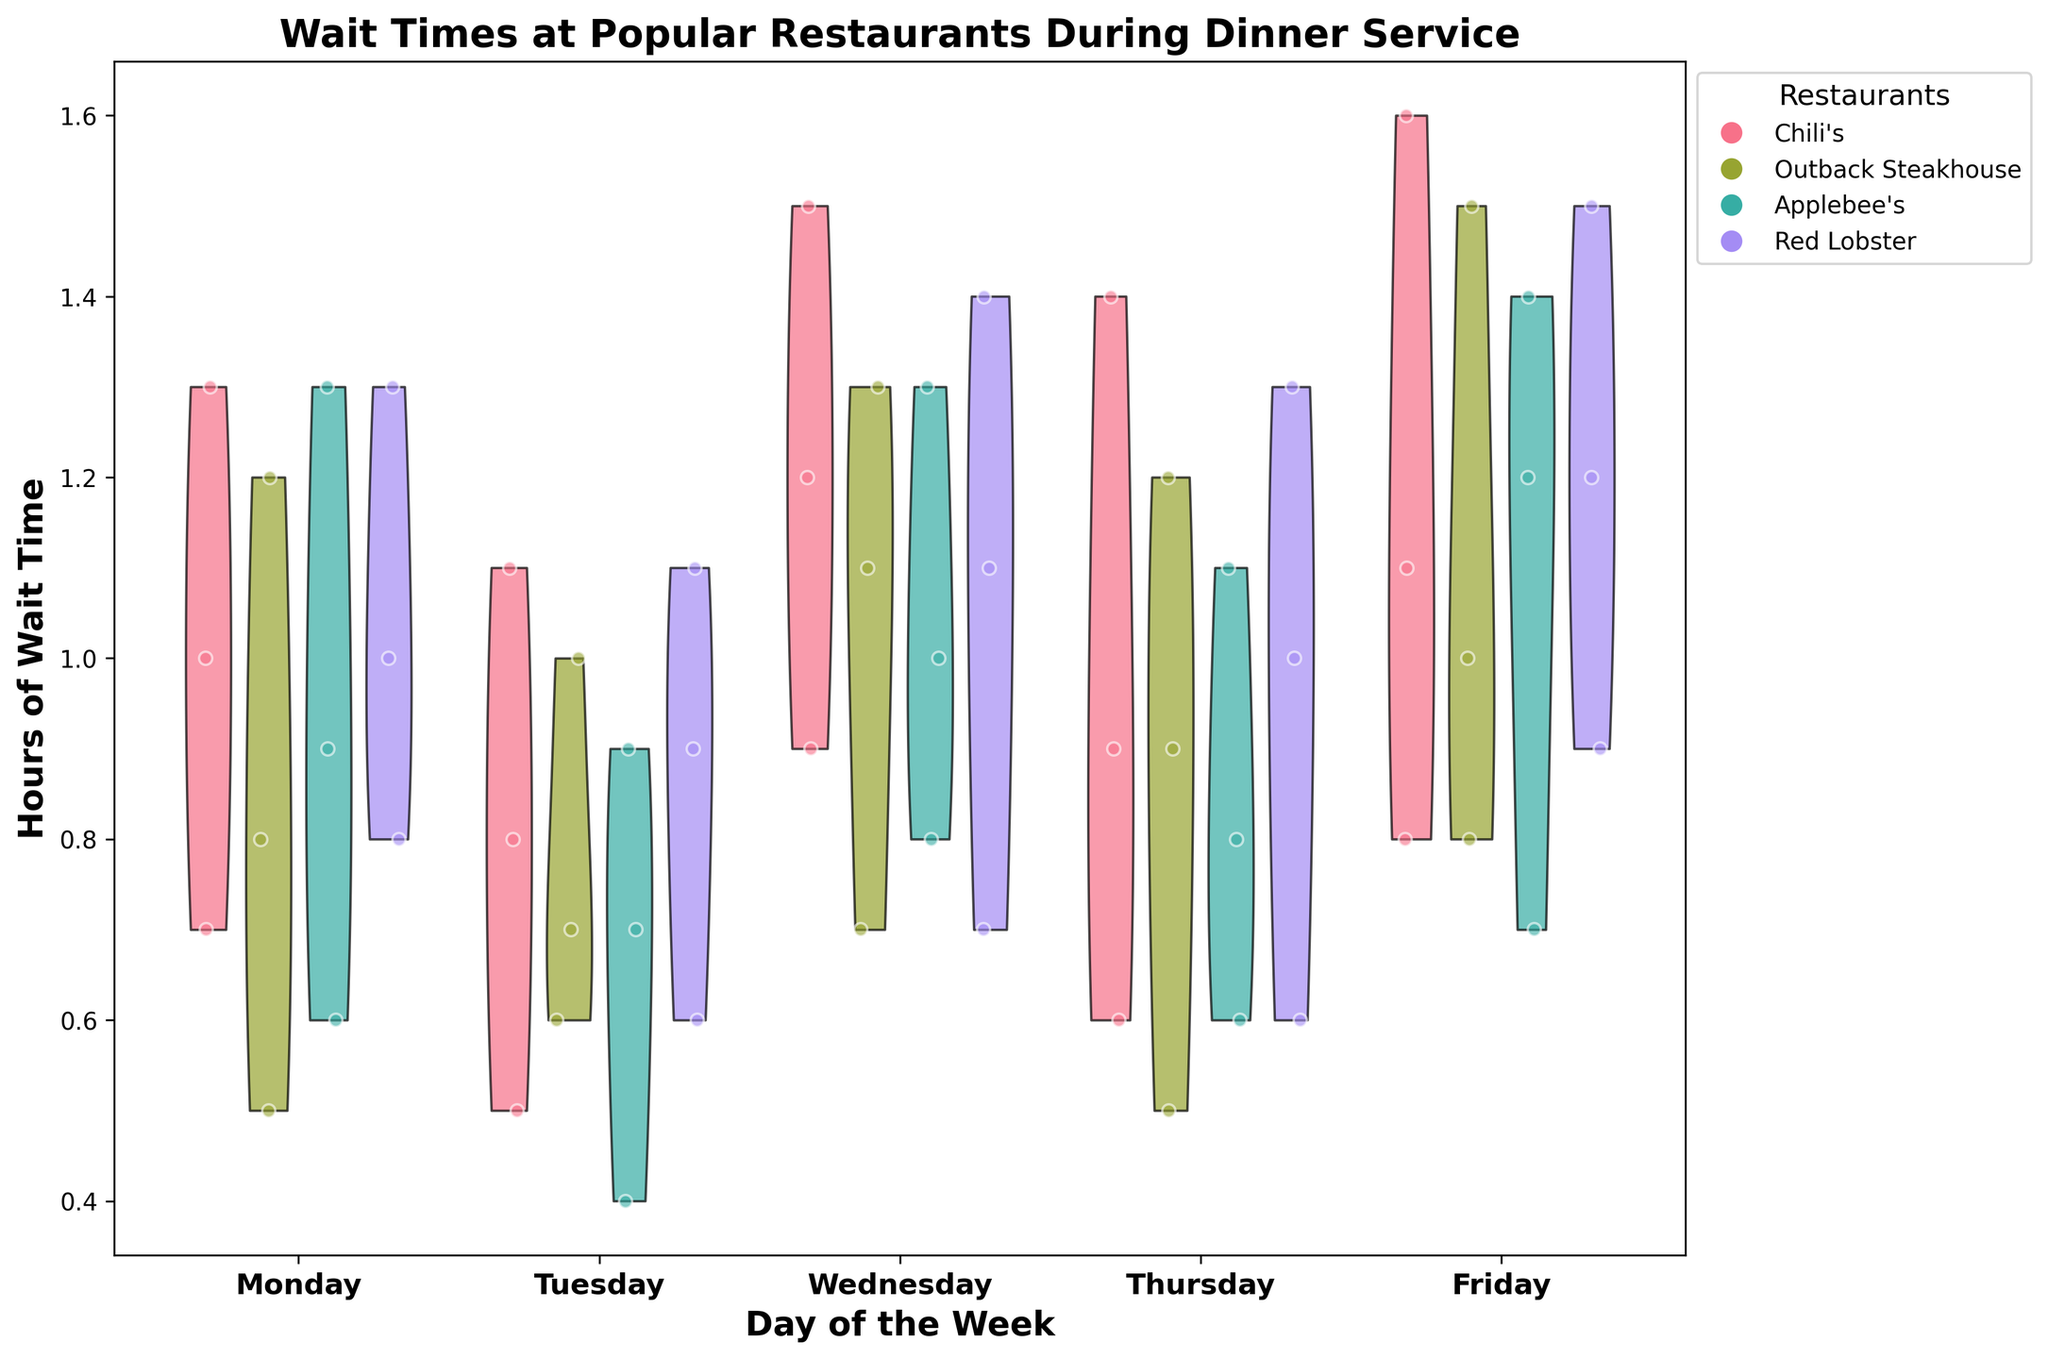What's the title of the figure? The title of the figure is usually located at the top center of the chart. It provides a summary of what the chart represents. Here, it says, "Wait Times at Popular Restaurants During Dinner Service."
Answer: Wait Times at Popular Restaurants During Dinner Service What are the labels on the x-axis? The x-axis labels represent the days of the week. Each tick corresponds to a day from Monday to Friday.
Answer: Monday, Tuesday, Wednesday, Thursday, Friday How many restaurants are compared in this figure? The legend lists the names of the restaurants included in the dataset. Each unique color and label correspond to a different restaurant. There are four restaurants: Chili's, Outback Steakhouse, Applebee's, and Red Lobster.
Answer: 4 Which day of the week has the highest wait time at Chili's? By looking at the violin plots and the jittered points for Chili's, the highest wait time can be identified. The plot for Friday shows the highest point compared to other days.
Answer: Friday Which restaurant generally has the lowest wait times on Monday? To determine this, compare the lower bounds of the violin plots for each restaurant on Monday. Applebee's shows the lowest minimum values.
Answer: Applebee's On which day is the wait time distribution the widest for Red Lobster? The width of the violin plot indicates the spread of the data. The day with the widest spread for Red Lobster can be identified by comparing the violin plot widths for each day. Wednesday has a significantly wider distribution.
Answer: Wednesday Compare the average wait time on Wednesday for all restaurants. Which restaurant has the longest average wait time? To find the longest average wait time, compare the central tendency of the jittered points (distribution center of the violin plot). Chili's appears to have the highest average wait time on Wednesday.
Answer: Chili's Which restaurant shows more variability in wait times throughout the week? Variability can be observed by examining the spread of violin plots across all days. Red Lobster shows wider and more varied distributions throughout the week.
Answer: Red Lobster What is the shortest wait time observed at Outback Steakhouse, and on which day did it occur? Look at the lower bounds of the jittered points at Outback Steakhouse. The shortest wait time observed is 0.5, which occurs on Monday and Thursday.
Answer: 0.5, Monday and Thursday 